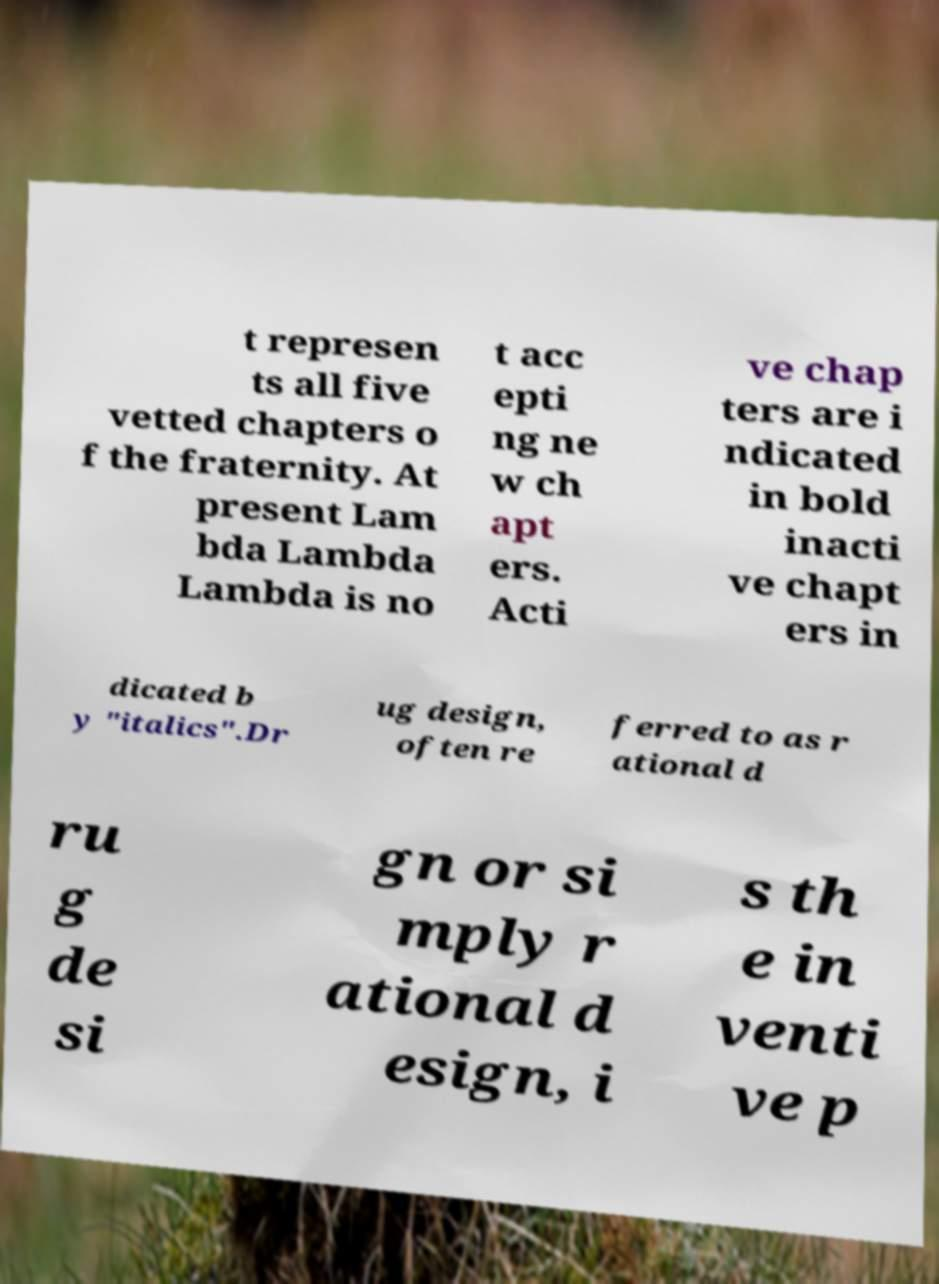Could you extract and type out the text from this image? t represen ts all five vetted chapters o f the fraternity. At present Lam bda Lambda Lambda is no t acc epti ng ne w ch apt ers. Acti ve chap ters are i ndicated in bold inacti ve chapt ers in dicated b y "italics".Dr ug design, often re ferred to as r ational d ru g de si gn or si mply r ational d esign, i s th e in venti ve p 